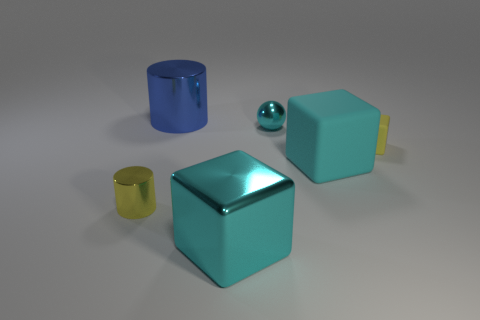What shape is the thing that is the same color as the tiny rubber block?
Give a very brief answer. Cylinder. Does the blue object have the same material as the sphere?
Offer a very short reply. Yes. How many other things are the same shape as the large rubber object?
Offer a very short reply. 2. What size is the cyan thing that is both behind the cyan metal block and in front of the yellow block?
Offer a terse response. Large. How many matte things are small cyan things or large cyan spheres?
Make the answer very short. 0. There is a large metallic thing behind the tiny matte cube; does it have the same shape as the large object in front of the tiny metallic cylinder?
Give a very brief answer. No. Is there a large cyan cylinder that has the same material as the cyan ball?
Keep it short and to the point. No. The metallic ball is what color?
Provide a succinct answer. Cyan. What size is the thing behind the small sphere?
Keep it short and to the point. Large. How many matte objects have the same color as the large metallic block?
Offer a very short reply. 1. 